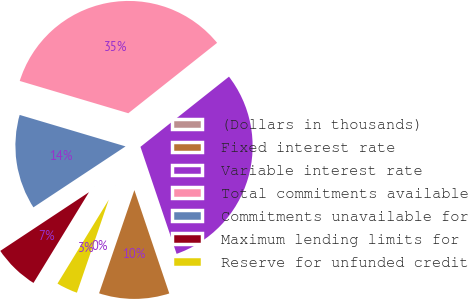<chart> <loc_0><loc_0><loc_500><loc_500><pie_chart><fcel>(Dollars in thousands)<fcel>Fixed interest rate<fcel>Variable interest rate<fcel>Total commitments available<fcel>Commitments unavailable for<fcel>Maximum lending limits for<fcel>Reserve for unfunded credit<nl><fcel>0.01%<fcel>10.43%<fcel>30.48%<fcel>34.73%<fcel>13.9%<fcel>6.96%<fcel>3.48%<nl></chart> 